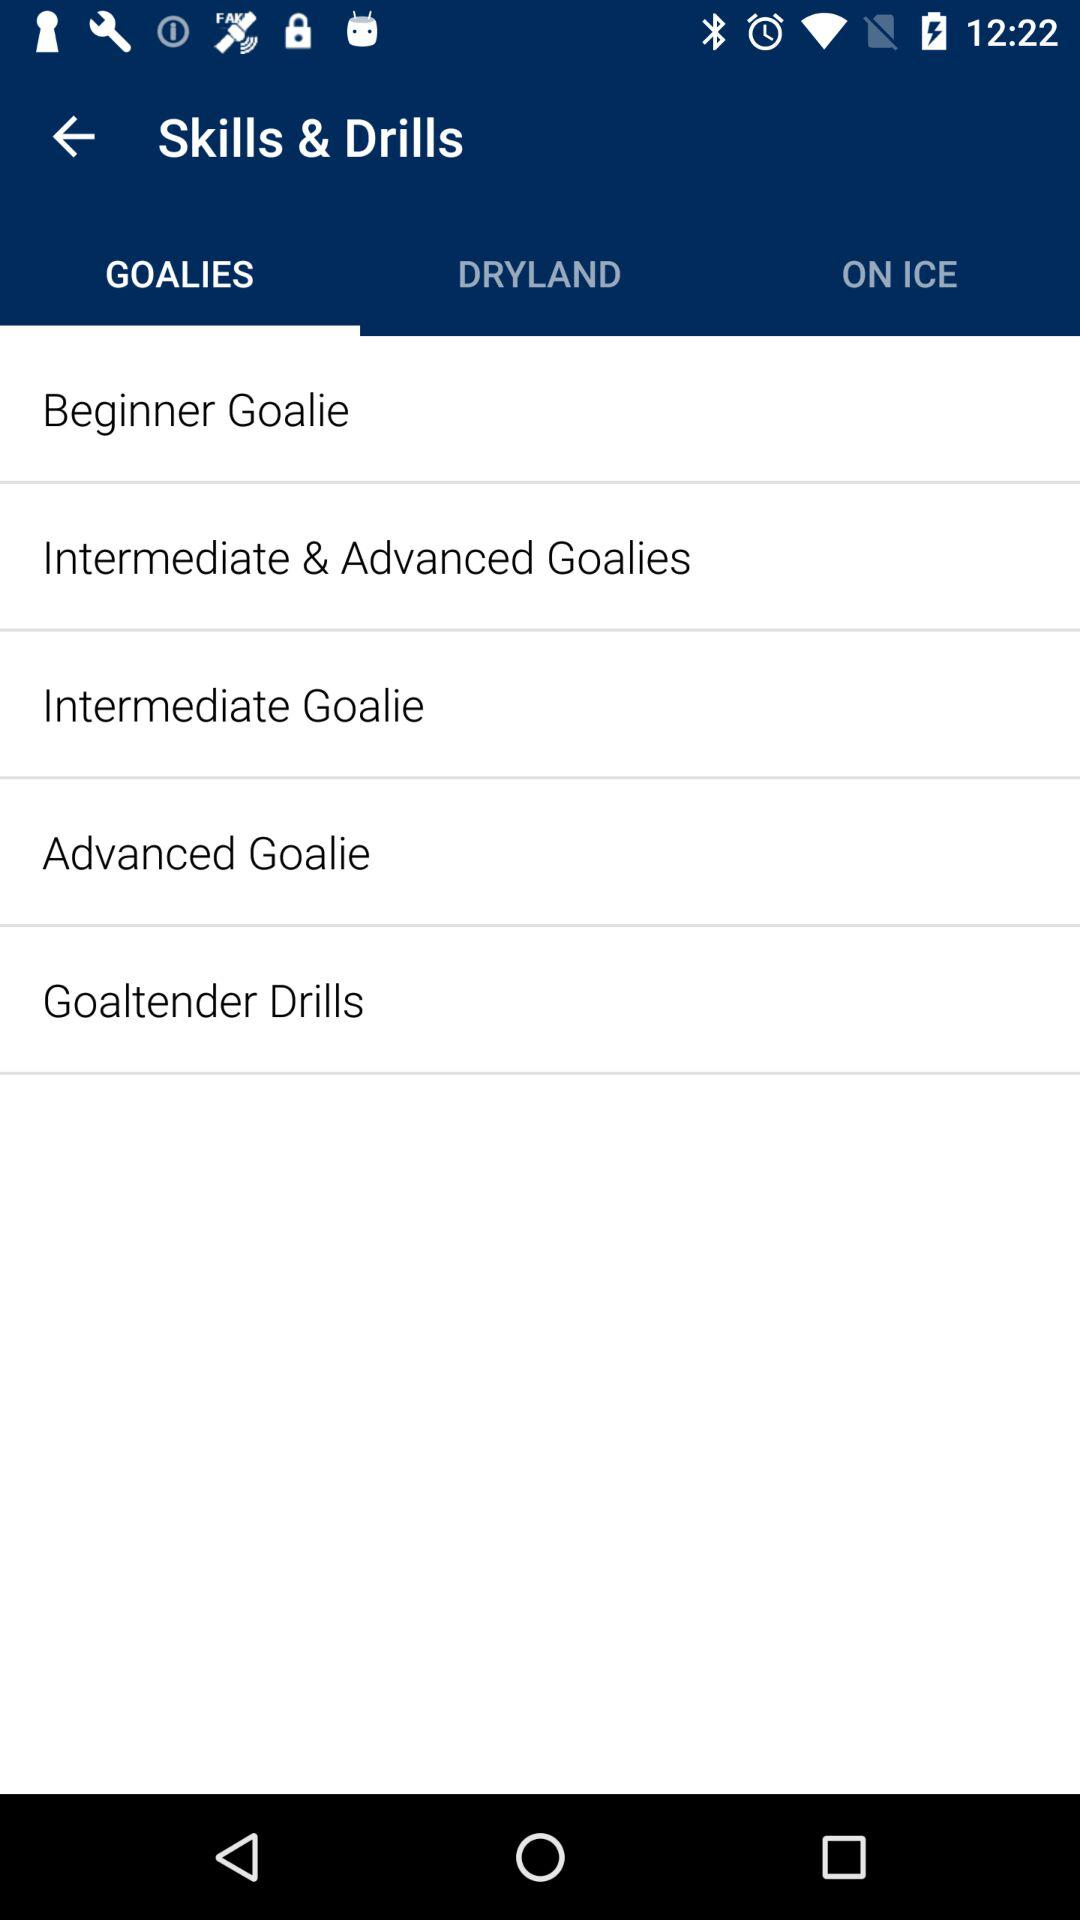Which tab am I on? You are on the "GOALIES" tab. 